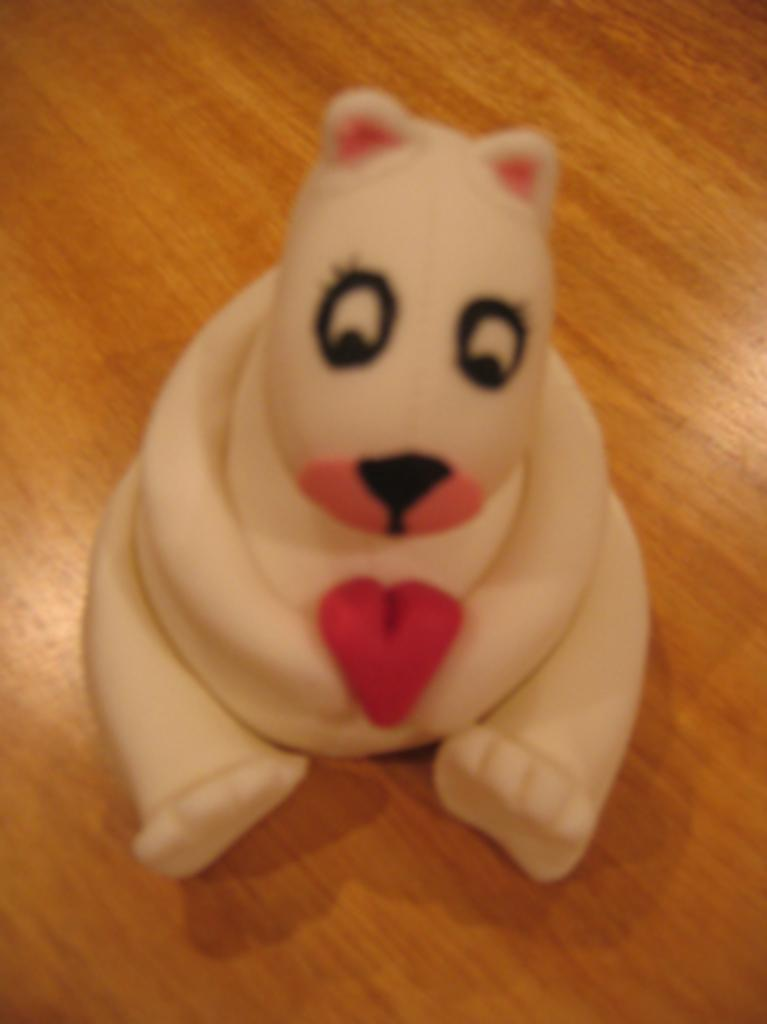What is the color of the toy in the image? The toy in the image is white. What is the toy placed on in the image? The white toy is on a wooden object. What type of thrill can be experienced by the card in the image? There is no card present in the image, and therefore no such experience can be observed. 